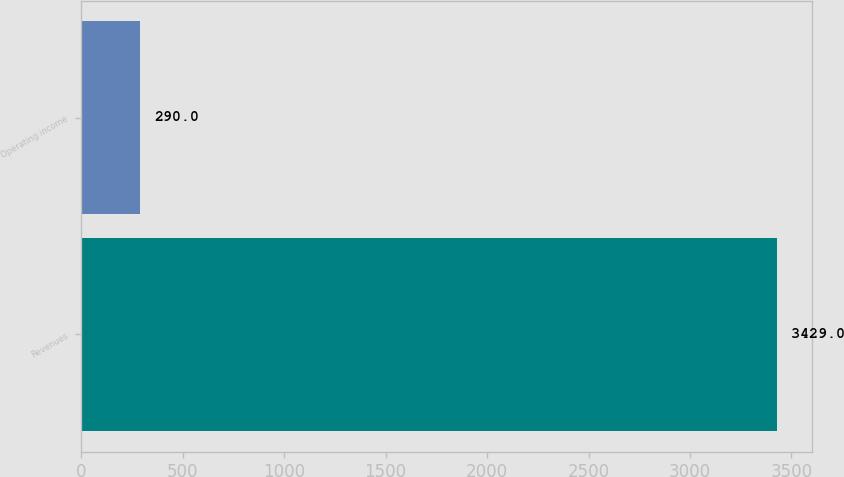Convert chart to OTSL. <chart><loc_0><loc_0><loc_500><loc_500><bar_chart><fcel>Revenues<fcel>Operating income<nl><fcel>3429<fcel>290<nl></chart> 